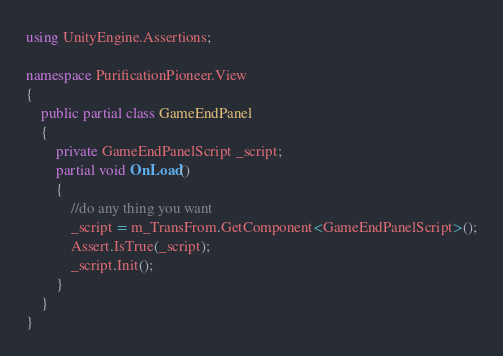<code> <loc_0><loc_0><loc_500><loc_500><_C#_>using UnityEngine.Assertions;

namespace PurificationPioneer.View
{
	public partial class GameEndPanel
	{
		private GameEndPanelScript _script;
		partial void OnLoad()
		{
			//do any thing you want
			_script = m_TransFrom.GetComponent<GameEndPanelScript>();
			Assert.IsTrue(_script);
			_script.Init();
		}
	}
}
</code> 